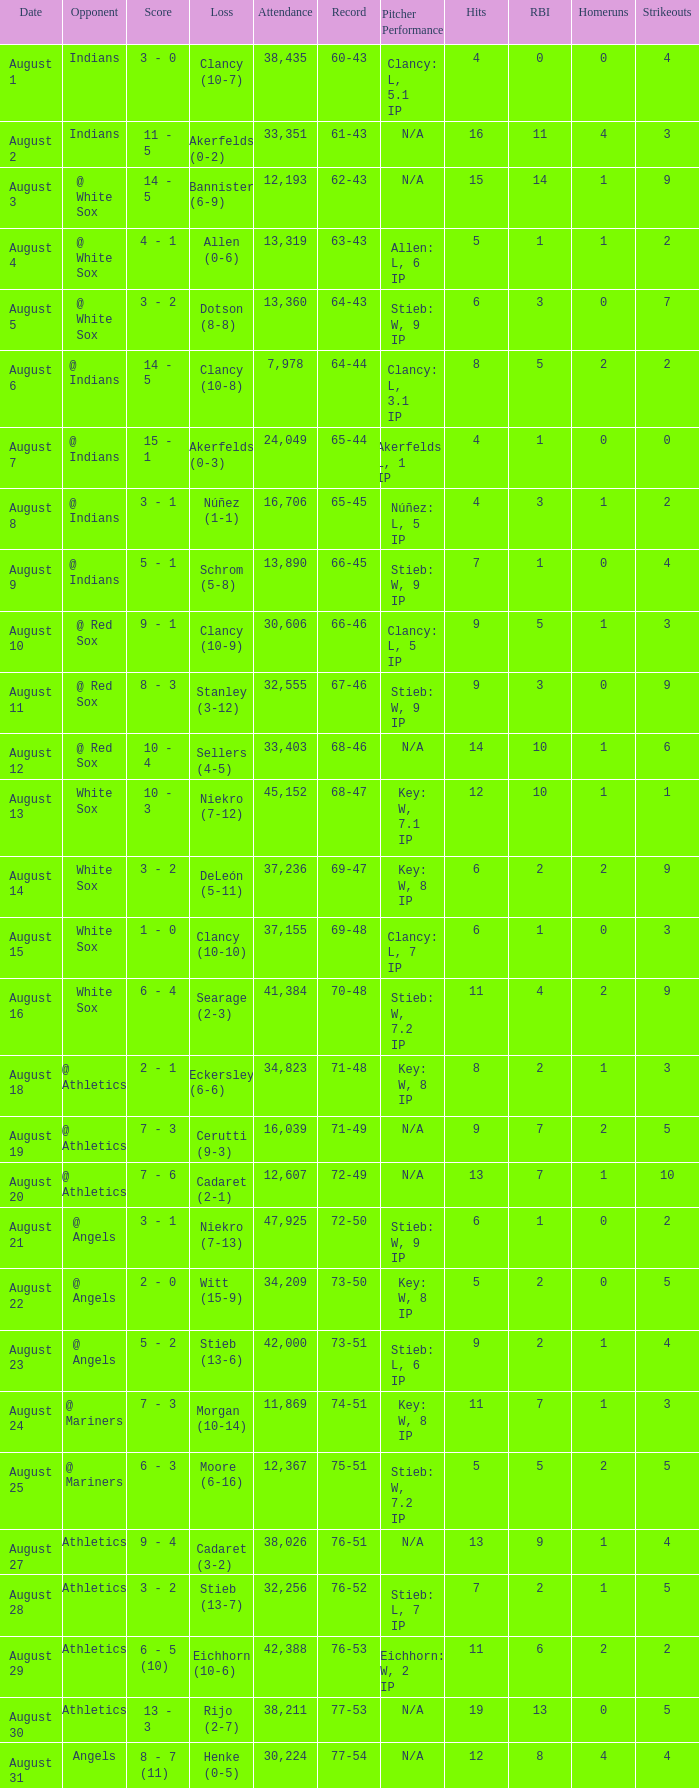What was the attendance when the record was 77-54? 30224.0. 